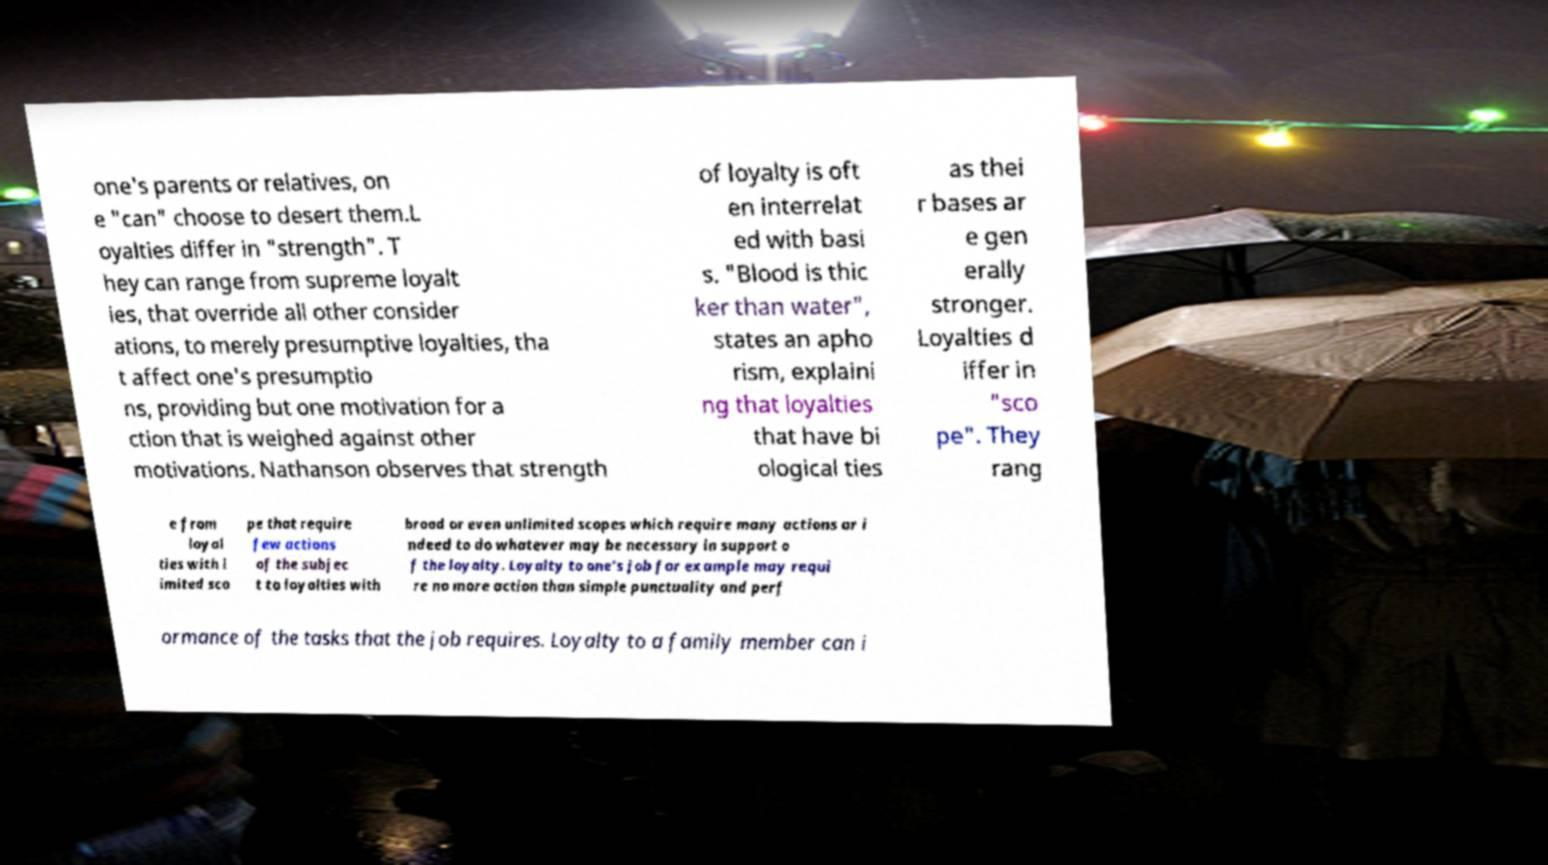Could you assist in decoding the text presented in this image and type it out clearly? one's parents or relatives, on e "can" choose to desert them.L oyalties differ in "strength". T hey can range from supreme loyalt ies, that override all other consider ations, to merely presumptive loyalties, tha t affect one's presumptio ns, providing but one motivation for a ction that is weighed against other motivations. Nathanson observes that strength of loyalty is oft en interrelat ed with basi s. "Blood is thic ker than water", states an apho rism, explaini ng that loyalties that have bi ological ties as thei r bases ar e gen erally stronger. Loyalties d iffer in "sco pe". They rang e from loyal ties with l imited sco pe that require few actions of the subjec t to loyalties with broad or even unlimited scopes which require many actions or i ndeed to do whatever may be necessary in support o f the loyalty. Loyalty to one's job for example may requi re no more action than simple punctuality and perf ormance of the tasks that the job requires. Loyalty to a family member can i 